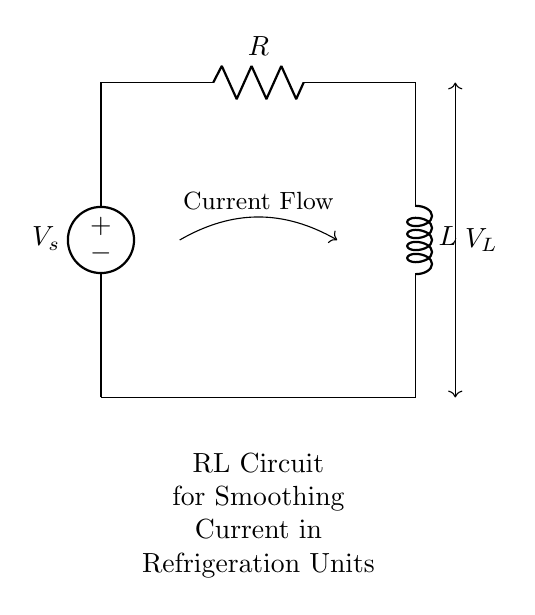What is the source voltage in this circuit? The source voltage is labeled as V_s, which is the voltage provided to the circuit.
Answer: V_s What are the components used in this RL circuit? The components are a resistor (R) and an inductor (L), which are connected in series.
Answer: Resistor and inductor What is the direction of current flow indicated in the diagram? The direction of current flow is represented by an arrow pointing from the voltage source to the resistor and inductor.
Answer: From voltage source to components How are the resistor and inductor connected in this circuit? The resistor and inductor are connected in series, meaning the current flows through the resistor first and then through the inductor.
Answer: In series What is the purpose of using the RL circuit in refrigeration units? The purpose of the RL circuit is to smooth current fluctuations, providing a more stable current to the refrigeration unit.
Answer: Smoothing current fluctuations Why is there a voltage drop across the inductor in this circuit? The voltage drop across the inductor occurs because it opposes changes in current flow, storing energy in the magnetic field created by the current.
Answer: It opposes current changes 